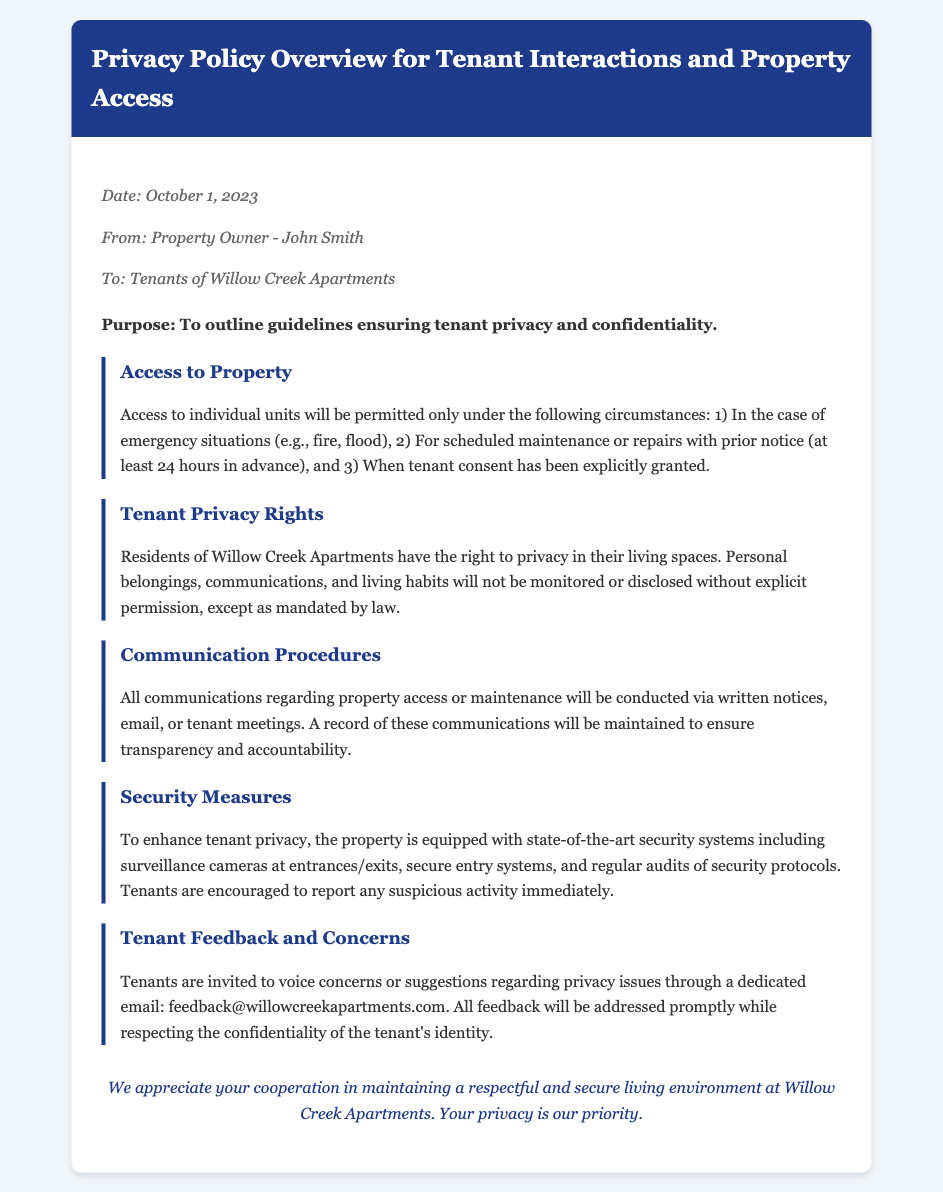What is the date of the memo? The date of the memo is explicitly mentioned in the meta-info section.
Answer: October 1, 2023 Who is the property owner? The name of the property owner is noted in the meta-info section.
Answer: John Smith What is the purpose of the memo? The purpose of the memo is stated clearly at the beginning of the memo content.
Answer: To outline guidelines ensuring tenant privacy and confidentiality How much notice is required for scheduled maintenance? The memo specifies the required notice period for scheduled maintenance under the Access to Property section.
Answer: 24 hours What should tenants do if they notice suspicious activity? The Security Measures section suggests a specific action for tenants to undertake.
Answer: Report immediately What communication methods are used for property access? The memo lists the ways communications are conducted under the Communication Procedures section.
Answer: Written notices, email, tenant meetings What is the dedicated email for tenant feedback? The email address for tenant feedback is provided in the Tenant Feedback and Concerns section.
Answer: feedback@willowcreekapartments.com What type of security systems are mentioned? The Security Measures section includes details on security systems implemented on the property.
Answer: Surveillance cameras, secure entry systems What rights do residents have regarding their personal belongings? The Tenant Privacy Rights section details specific rights granted to residents about personal belongings.
Answer: Not monitored or disclosed without explicit permission 